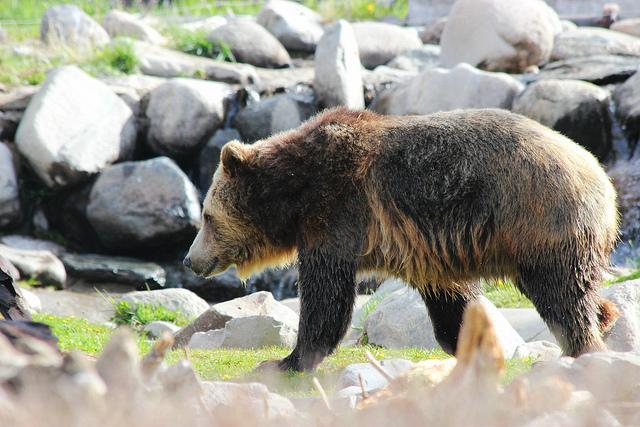What kind of bear is pictured?
Be succinct. Brown. Is the bear climbing a mountain?
Give a very brief answer. No. What is this animal?
Write a very short answer. Bear. 